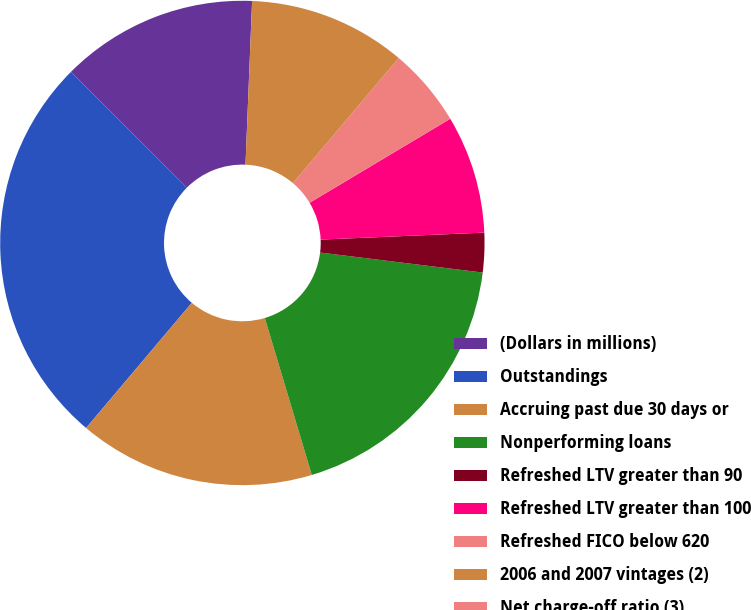Convert chart to OTSL. <chart><loc_0><loc_0><loc_500><loc_500><pie_chart><fcel>(Dollars in millions)<fcel>Outstandings<fcel>Accruing past due 30 days or<fcel>Nonperforming loans<fcel>Refreshed LTV greater than 90<fcel>Refreshed LTV greater than 100<fcel>Refreshed FICO below 620<fcel>2006 and 2007 vintages (2)<fcel>Net charge-off ratio (3)<nl><fcel>13.16%<fcel>26.32%<fcel>15.79%<fcel>18.42%<fcel>2.63%<fcel>7.89%<fcel>5.26%<fcel>10.53%<fcel>0.0%<nl></chart> 